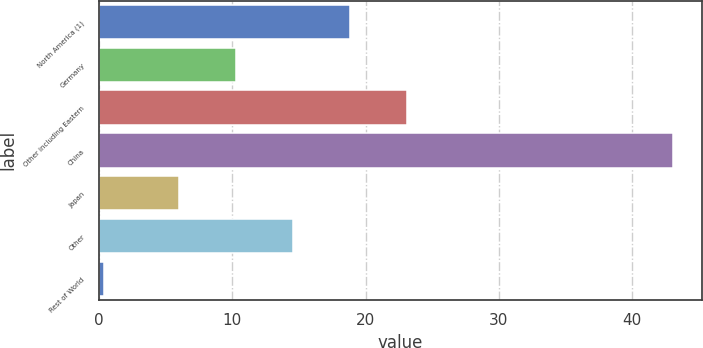Convert chart to OTSL. <chart><loc_0><loc_0><loc_500><loc_500><bar_chart><fcel>North America (1)<fcel>Germany<fcel>Other including Eastern<fcel>China<fcel>Japan<fcel>Other<fcel>Rest of World<nl><fcel>18.81<fcel>10.27<fcel>23.08<fcel>43.1<fcel>6<fcel>14.54<fcel>0.4<nl></chart> 